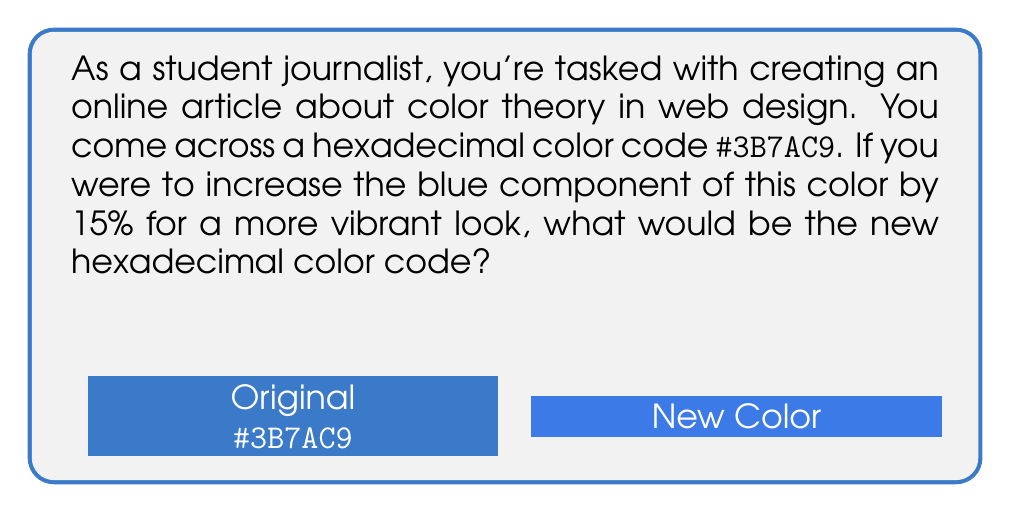Solve this math problem. Let's approach this step-by-step:

1) First, we need to understand the hexadecimal color code:
   #3B7AC9 = Red: 3B, Green: 7A, Blue: C9

2) Convert C9 (blue component) from hexadecimal to decimal:
   $C9_{16} = (12 \times 16^1) + (9 \times 16^0) = 192 + 9 = 201_{10}$

3) Calculate 15% increase:
   $15\% \text{ of } 201 = 0.15 \times 201 = 30.15$

4) Add this increase to the original value:
   $201 + 30.15 = 231.15$

5) Round to the nearest integer:
   $231.15 \approx 231$

6) Convert 231 back to hexadecimal:
   $231 \div 16 = 14 \text{ remainder } 7$
   $14 = \text{E in hexadecimal}$
   So, $231_{10} = \text{E7}_{16}$

7) The new color code will be #3B7AE7

Note: The red (3B) and green (7A) components remain unchanged.
Answer: #3B7AE7 